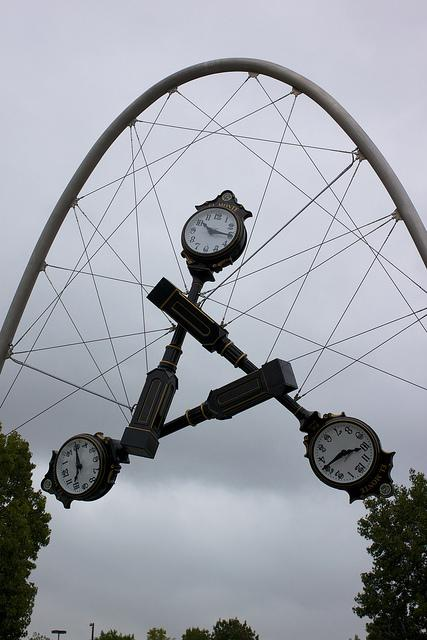Why are the clocks all facing different directions? Please explain your reasoning. gimmick. This is likely a sculpture and possibly commentary about different time zones. 